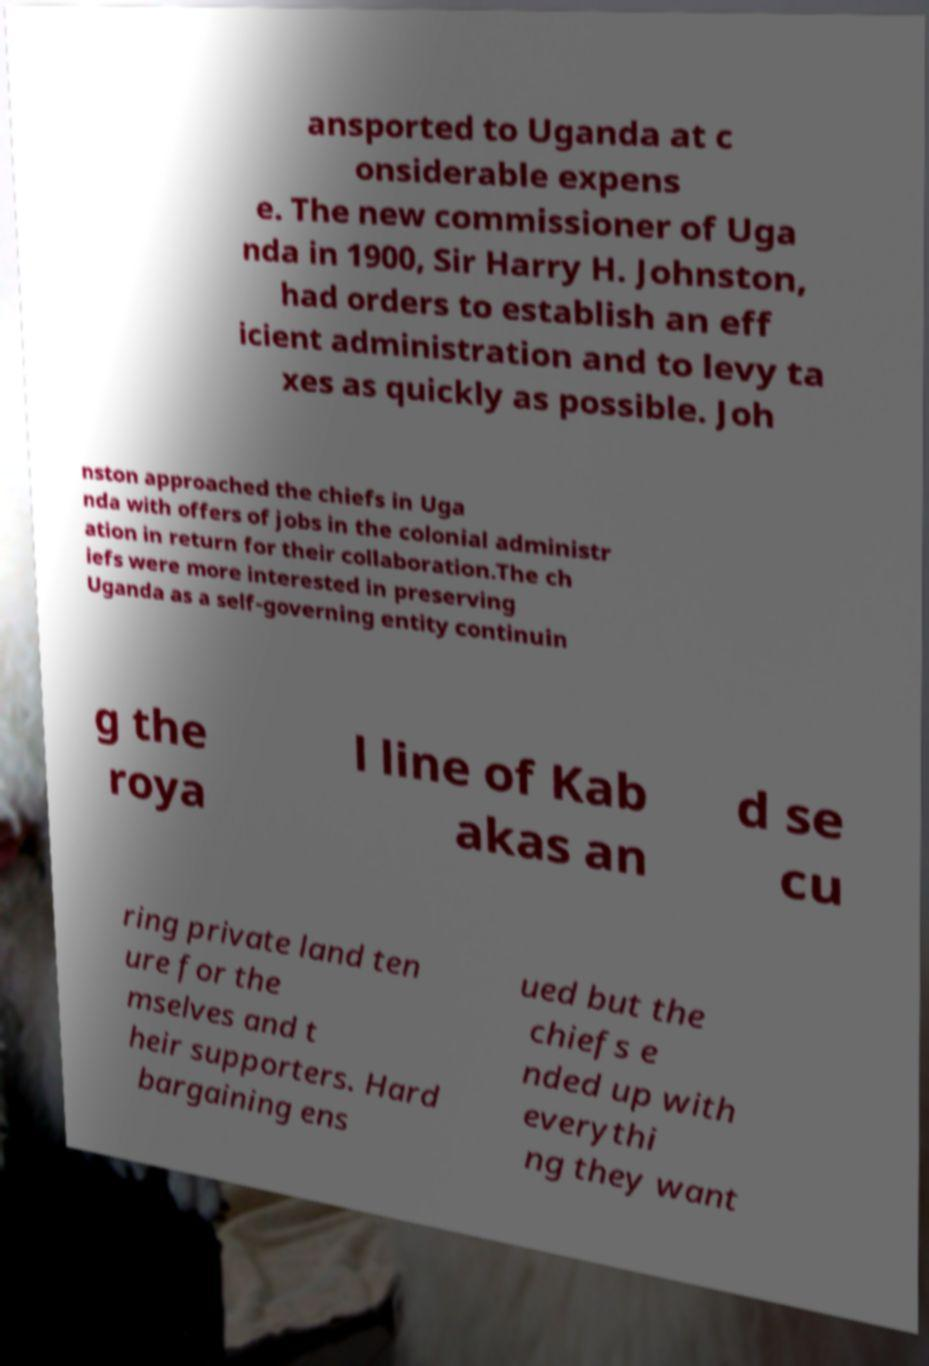Please read and relay the text visible in this image. What does it say? ansported to Uganda at c onsiderable expens e. The new commissioner of Uga nda in 1900, Sir Harry H. Johnston, had orders to establish an eff icient administration and to levy ta xes as quickly as possible. Joh nston approached the chiefs in Uga nda with offers of jobs in the colonial administr ation in return for their collaboration.The ch iefs were more interested in preserving Uganda as a self-governing entity continuin g the roya l line of Kab akas an d se cu ring private land ten ure for the mselves and t heir supporters. Hard bargaining ens ued but the chiefs e nded up with everythi ng they want 